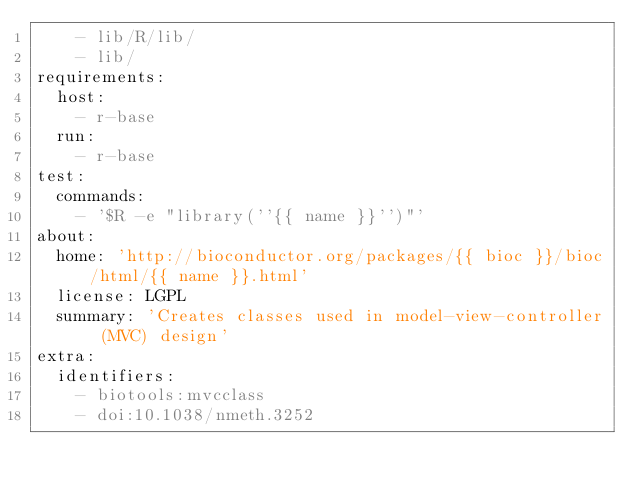Convert code to text. <code><loc_0><loc_0><loc_500><loc_500><_YAML_>    - lib/R/lib/
    - lib/
requirements:
  host:
    - r-base
  run:
    - r-base
test:
  commands:
    - '$R -e "library(''{{ name }}'')"'
about:
  home: 'http://bioconductor.org/packages/{{ bioc }}/bioc/html/{{ name }}.html'
  license: LGPL
  summary: 'Creates classes used in model-view-controller (MVC) design'
extra:
  identifiers:
    - biotools:mvcclass
    - doi:10.1038/nmeth.3252
</code> 